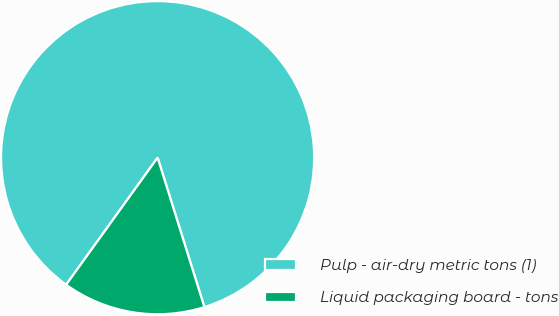Convert chart to OTSL. <chart><loc_0><loc_0><loc_500><loc_500><pie_chart><fcel>Pulp - air-dry metric tons (1)<fcel>Liquid packaging board - tons<nl><fcel>85.24%<fcel>14.76%<nl></chart> 